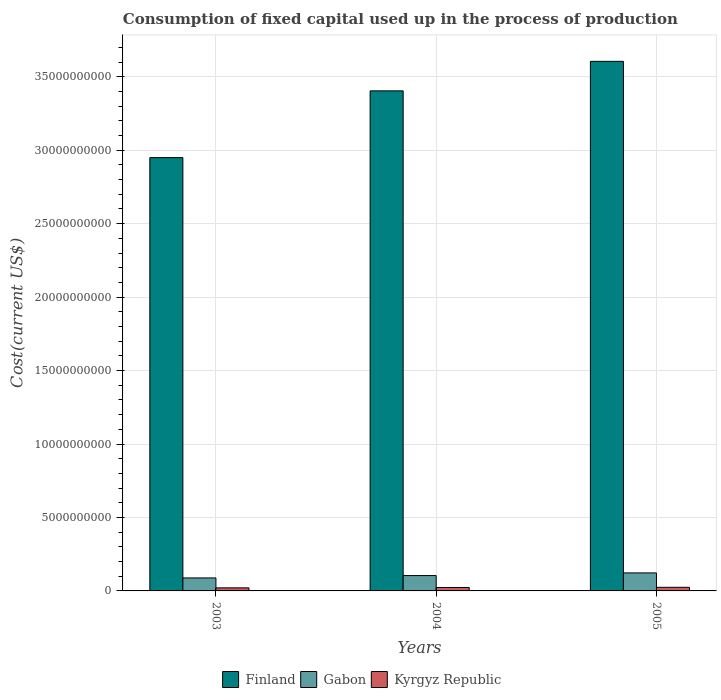How many groups of bars are there?
Keep it short and to the point. 3. Are the number of bars per tick equal to the number of legend labels?
Give a very brief answer. Yes. Are the number of bars on each tick of the X-axis equal?
Your answer should be compact. Yes. How many bars are there on the 2nd tick from the left?
Offer a very short reply. 3. How many bars are there on the 2nd tick from the right?
Give a very brief answer. 3. What is the amount consumed in the process of production in Gabon in 2004?
Keep it short and to the point. 1.04e+09. Across all years, what is the maximum amount consumed in the process of production in Finland?
Keep it short and to the point. 3.60e+1. Across all years, what is the minimum amount consumed in the process of production in Gabon?
Your response must be concise. 8.84e+08. In which year was the amount consumed in the process of production in Kyrgyz Republic minimum?
Provide a succinct answer. 2003. What is the total amount consumed in the process of production in Finland in the graph?
Offer a very short reply. 9.96e+1. What is the difference between the amount consumed in the process of production in Finland in 2003 and that in 2004?
Your response must be concise. -4.54e+09. What is the difference between the amount consumed in the process of production in Gabon in 2003 and the amount consumed in the process of production in Kyrgyz Republic in 2004?
Provide a short and direct response. 6.50e+08. What is the average amount consumed in the process of production in Kyrgyz Republic per year?
Keep it short and to the point. 2.30e+08. In the year 2005, what is the difference between the amount consumed in the process of production in Kyrgyz Republic and amount consumed in the process of production in Finland?
Your response must be concise. -3.58e+1. In how many years, is the amount consumed in the process of production in Finland greater than 6000000000 US$?
Offer a very short reply. 3. What is the ratio of the amount consumed in the process of production in Finland in 2004 to that in 2005?
Your answer should be very brief. 0.94. What is the difference between the highest and the second highest amount consumed in the process of production in Finland?
Your answer should be compact. 2.01e+09. What is the difference between the highest and the lowest amount consumed in the process of production in Finland?
Keep it short and to the point. 6.55e+09. Is the sum of the amount consumed in the process of production in Gabon in 2003 and 2004 greater than the maximum amount consumed in the process of production in Kyrgyz Republic across all years?
Your answer should be compact. Yes. What does the 1st bar from the right in 2005 represents?
Give a very brief answer. Kyrgyz Republic. Is it the case that in every year, the sum of the amount consumed in the process of production in Gabon and amount consumed in the process of production in Kyrgyz Republic is greater than the amount consumed in the process of production in Finland?
Make the answer very short. No. How many bars are there?
Offer a terse response. 9. Are all the bars in the graph horizontal?
Make the answer very short. No. How many years are there in the graph?
Keep it short and to the point. 3. Are the values on the major ticks of Y-axis written in scientific E-notation?
Offer a very short reply. No. Does the graph contain any zero values?
Offer a terse response. No. Where does the legend appear in the graph?
Offer a terse response. Bottom center. What is the title of the graph?
Provide a short and direct response. Consumption of fixed capital used up in the process of production. Does "High income: OECD" appear as one of the legend labels in the graph?
Your answer should be compact. No. What is the label or title of the X-axis?
Make the answer very short. Years. What is the label or title of the Y-axis?
Provide a short and direct response. Cost(current US$). What is the Cost(current US$) of Finland in 2003?
Ensure brevity in your answer.  2.95e+1. What is the Cost(current US$) of Gabon in 2003?
Give a very brief answer. 8.84e+08. What is the Cost(current US$) in Kyrgyz Republic in 2003?
Your response must be concise. 2.09e+08. What is the Cost(current US$) of Finland in 2004?
Offer a terse response. 3.40e+1. What is the Cost(current US$) of Gabon in 2004?
Your response must be concise. 1.04e+09. What is the Cost(current US$) of Kyrgyz Republic in 2004?
Provide a succinct answer. 2.34e+08. What is the Cost(current US$) of Finland in 2005?
Provide a short and direct response. 3.60e+1. What is the Cost(current US$) of Gabon in 2005?
Ensure brevity in your answer.  1.23e+09. What is the Cost(current US$) in Kyrgyz Republic in 2005?
Provide a short and direct response. 2.46e+08. Across all years, what is the maximum Cost(current US$) of Finland?
Your answer should be very brief. 3.60e+1. Across all years, what is the maximum Cost(current US$) in Gabon?
Your answer should be compact. 1.23e+09. Across all years, what is the maximum Cost(current US$) in Kyrgyz Republic?
Provide a short and direct response. 2.46e+08. Across all years, what is the minimum Cost(current US$) of Finland?
Give a very brief answer. 2.95e+1. Across all years, what is the minimum Cost(current US$) in Gabon?
Ensure brevity in your answer.  8.84e+08. Across all years, what is the minimum Cost(current US$) of Kyrgyz Republic?
Offer a terse response. 2.09e+08. What is the total Cost(current US$) in Finland in the graph?
Make the answer very short. 9.96e+1. What is the total Cost(current US$) in Gabon in the graph?
Keep it short and to the point. 3.15e+09. What is the total Cost(current US$) in Kyrgyz Republic in the graph?
Offer a very short reply. 6.89e+08. What is the difference between the Cost(current US$) of Finland in 2003 and that in 2004?
Give a very brief answer. -4.54e+09. What is the difference between the Cost(current US$) of Gabon in 2003 and that in 2004?
Offer a very short reply. -1.61e+08. What is the difference between the Cost(current US$) of Kyrgyz Republic in 2003 and that in 2004?
Provide a succinct answer. -2.48e+07. What is the difference between the Cost(current US$) in Finland in 2003 and that in 2005?
Offer a very short reply. -6.55e+09. What is the difference between the Cost(current US$) of Gabon in 2003 and that in 2005?
Your response must be concise. -3.42e+08. What is the difference between the Cost(current US$) of Kyrgyz Republic in 2003 and that in 2005?
Your answer should be very brief. -3.66e+07. What is the difference between the Cost(current US$) in Finland in 2004 and that in 2005?
Offer a very short reply. -2.01e+09. What is the difference between the Cost(current US$) in Gabon in 2004 and that in 2005?
Your answer should be compact. -1.81e+08. What is the difference between the Cost(current US$) in Kyrgyz Republic in 2004 and that in 2005?
Give a very brief answer. -1.19e+07. What is the difference between the Cost(current US$) in Finland in 2003 and the Cost(current US$) in Gabon in 2004?
Your answer should be compact. 2.84e+1. What is the difference between the Cost(current US$) in Finland in 2003 and the Cost(current US$) in Kyrgyz Republic in 2004?
Provide a succinct answer. 2.93e+1. What is the difference between the Cost(current US$) in Gabon in 2003 and the Cost(current US$) in Kyrgyz Republic in 2004?
Offer a very short reply. 6.50e+08. What is the difference between the Cost(current US$) in Finland in 2003 and the Cost(current US$) in Gabon in 2005?
Provide a succinct answer. 2.83e+1. What is the difference between the Cost(current US$) in Finland in 2003 and the Cost(current US$) in Kyrgyz Republic in 2005?
Keep it short and to the point. 2.92e+1. What is the difference between the Cost(current US$) in Gabon in 2003 and the Cost(current US$) in Kyrgyz Republic in 2005?
Your answer should be compact. 6.38e+08. What is the difference between the Cost(current US$) of Finland in 2004 and the Cost(current US$) of Gabon in 2005?
Offer a terse response. 3.28e+1. What is the difference between the Cost(current US$) of Finland in 2004 and the Cost(current US$) of Kyrgyz Republic in 2005?
Your response must be concise. 3.38e+1. What is the difference between the Cost(current US$) of Gabon in 2004 and the Cost(current US$) of Kyrgyz Republic in 2005?
Your response must be concise. 7.99e+08. What is the average Cost(current US$) of Finland per year?
Keep it short and to the point. 3.32e+1. What is the average Cost(current US$) of Gabon per year?
Provide a short and direct response. 1.05e+09. What is the average Cost(current US$) in Kyrgyz Republic per year?
Keep it short and to the point. 2.30e+08. In the year 2003, what is the difference between the Cost(current US$) in Finland and Cost(current US$) in Gabon?
Provide a short and direct response. 2.86e+1. In the year 2003, what is the difference between the Cost(current US$) in Finland and Cost(current US$) in Kyrgyz Republic?
Your answer should be compact. 2.93e+1. In the year 2003, what is the difference between the Cost(current US$) of Gabon and Cost(current US$) of Kyrgyz Republic?
Give a very brief answer. 6.75e+08. In the year 2004, what is the difference between the Cost(current US$) in Finland and Cost(current US$) in Gabon?
Your response must be concise. 3.30e+1. In the year 2004, what is the difference between the Cost(current US$) in Finland and Cost(current US$) in Kyrgyz Republic?
Ensure brevity in your answer.  3.38e+1. In the year 2004, what is the difference between the Cost(current US$) in Gabon and Cost(current US$) in Kyrgyz Republic?
Provide a short and direct response. 8.11e+08. In the year 2005, what is the difference between the Cost(current US$) of Finland and Cost(current US$) of Gabon?
Provide a short and direct response. 3.48e+1. In the year 2005, what is the difference between the Cost(current US$) in Finland and Cost(current US$) in Kyrgyz Republic?
Your answer should be compact. 3.58e+1. In the year 2005, what is the difference between the Cost(current US$) in Gabon and Cost(current US$) in Kyrgyz Republic?
Your response must be concise. 9.80e+08. What is the ratio of the Cost(current US$) in Finland in 2003 to that in 2004?
Provide a succinct answer. 0.87. What is the ratio of the Cost(current US$) in Gabon in 2003 to that in 2004?
Offer a very short reply. 0.85. What is the ratio of the Cost(current US$) in Kyrgyz Republic in 2003 to that in 2004?
Your response must be concise. 0.89. What is the ratio of the Cost(current US$) of Finland in 2003 to that in 2005?
Offer a terse response. 0.82. What is the ratio of the Cost(current US$) in Gabon in 2003 to that in 2005?
Offer a terse response. 0.72. What is the ratio of the Cost(current US$) in Kyrgyz Republic in 2003 to that in 2005?
Offer a very short reply. 0.85. What is the ratio of the Cost(current US$) of Finland in 2004 to that in 2005?
Provide a succinct answer. 0.94. What is the ratio of the Cost(current US$) in Gabon in 2004 to that in 2005?
Your answer should be very brief. 0.85. What is the ratio of the Cost(current US$) of Kyrgyz Republic in 2004 to that in 2005?
Provide a short and direct response. 0.95. What is the difference between the highest and the second highest Cost(current US$) in Finland?
Give a very brief answer. 2.01e+09. What is the difference between the highest and the second highest Cost(current US$) of Gabon?
Make the answer very short. 1.81e+08. What is the difference between the highest and the second highest Cost(current US$) in Kyrgyz Republic?
Your answer should be compact. 1.19e+07. What is the difference between the highest and the lowest Cost(current US$) of Finland?
Ensure brevity in your answer.  6.55e+09. What is the difference between the highest and the lowest Cost(current US$) in Gabon?
Your answer should be compact. 3.42e+08. What is the difference between the highest and the lowest Cost(current US$) of Kyrgyz Republic?
Give a very brief answer. 3.66e+07. 